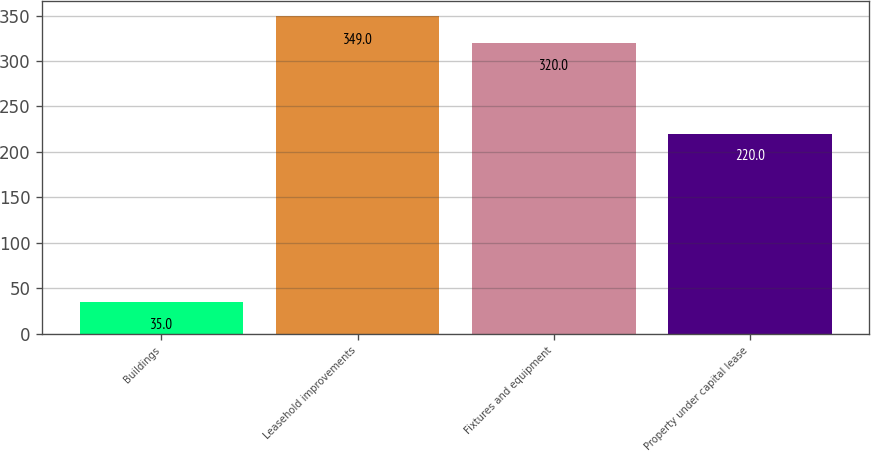<chart> <loc_0><loc_0><loc_500><loc_500><bar_chart><fcel>Buildings<fcel>Leasehold improvements<fcel>Fixtures and equipment<fcel>Property under capital lease<nl><fcel>35<fcel>349<fcel>320<fcel>220<nl></chart> 